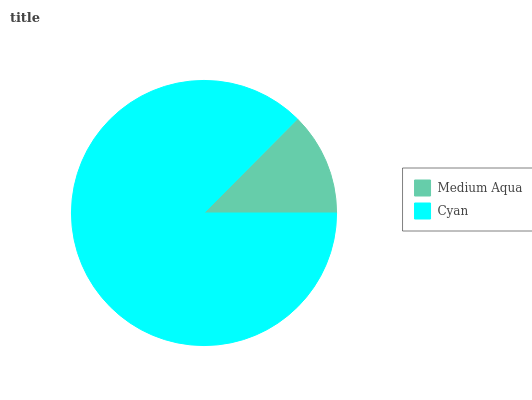Is Medium Aqua the minimum?
Answer yes or no. Yes. Is Cyan the maximum?
Answer yes or no. Yes. Is Cyan the minimum?
Answer yes or no. No. Is Cyan greater than Medium Aqua?
Answer yes or no. Yes. Is Medium Aqua less than Cyan?
Answer yes or no. Yes. Is Medium Aqua greater than Cyan?
Answer yes or no. No. Is Cyan less than Medium Aqua?
Answer yes or no. No. Is Cyan the high median?
Answer yes or no. Yes. Is Medium Aqua the low median?
Answer yes or no. Yes. Is Medium Aqua the high median?
Answer yes or no. No. Is Cyan the low median?
Answer yes or no. No. 